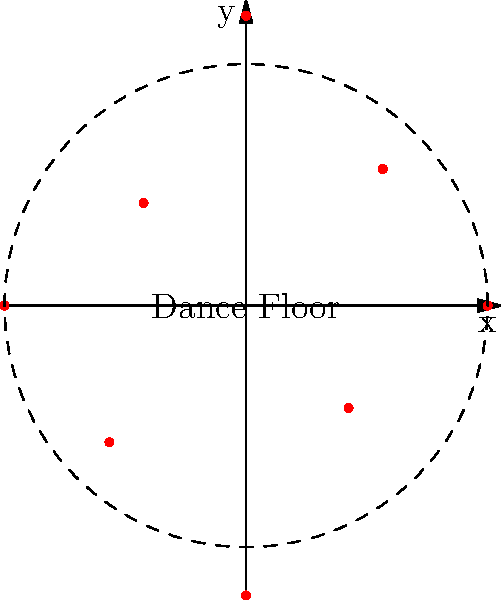In a circular club layout, speakers are positioned using polar coordinates $(r, \theta)$ where $r$ is the distance from the center in meters and $\theta$ is the angle in degrees. Given the speaker placement shown in the diagram, what is the total number of speakers that are exactly 5 meters from the center of the dance floor? To solve this problem, we need to analyze the polar coordinates of each speaker in the diagram. Let's break it down step-by-step:

1. The diagram shows 8 speakers placed around a circular dance floor.
2. Each speaker's position is represented by a red dot.
3. The dashed circle represents a radius of 5 meters from the center.
4. We need to count how many speakers are exactly on this 5-meter circle.

Let's examine each speaker's distance from the center:

- At 0°: The speaker is on the 5-meter circle.
- At 45°: The speaker is inside the 5-meter circle.
- At 90°: The speaker is outside the 5-meter circle.
- At 135°: The speaker is inside the 5-meter circle.
- At 180°: The speaker is on the 5-meter circle.
- At 225°: The speaker is inside the 5-meter circle.
- At 270°: The speaker is outside the 5-meter circle.
- At 315°: The speaker is inside the 5-meter circle.

Counting the speakers that are exactly on the 5-meter circle, we find that there are 2 such speakers: at 0° and 180°.
Answer: 2 